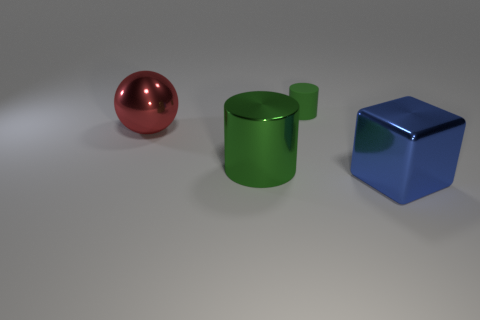How do the objects in the image differ from each other? The objects differ in color, shape, and size. The sphere is red and shiny, the cylinder is green with a matte finish, and the cube is blue and equally matte. The shapes include a perfect sphere, a cylindrical form with a protruding circular part, and a regular cube. These variations introduce an interesting contrast both in visual and geometric aspects. 